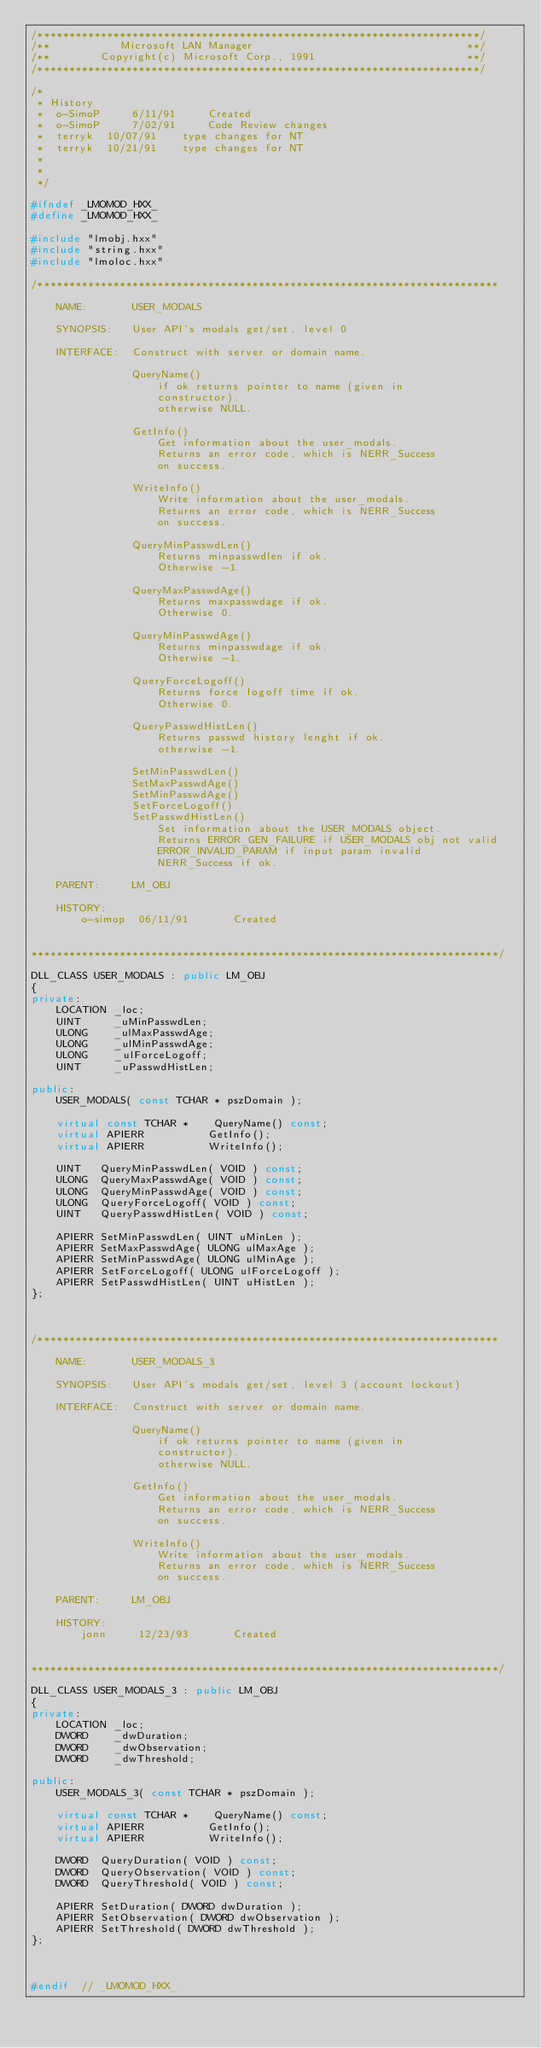Convert code to text. <code><loc_0><loc_0><loc_500><loc_500><_C++_>/**********************************************************************/
/**           Microsoft LAN Manager                                  **/
/**        Copyright(c) Microsoft Corp., 1991                        **/
/**********************************************************************/

/*
 * History
 *  o-SimoP     6/11/91     Created
 *  o-SimoP     7/02/91     Code Review changes
 *  terryk	10/07/91    type changes for NT
 *  terryk	10/21/91    type changes for NT
 *
 *
 */

#ifndef _LMOMOD_HXX_
#define _LMOMOD_HXX_

#include "lmobj.hxx"
#include "string.hxx"
#include "lmoloc.hxx"

/*************************************************************************

    NAME:       USER_MODALS

    SYNOPSIS:   User API's modals get/set, level 0

    INTERFACE:  Construct with server or domain name.

                QueryName()
                    if ok returns pointer to name (given in
                    constructor).
                    otherwise NULL.

                GetInfo()
                    Get information about the user_modals.
                    Returns an error code, which is NERR_Success
                    on success.

                WriteInfo()
                    Write information about the user_modals.
                    Returns an error code, which is NERR_Success
                    on success.

                QueryMinPasswdLen()
                    Returns minpasswdlen if ok.
                    Otherwise -1.

                QueryMaxPasswdAge()
                    Returns maxpasswdage if ok.
                    Otherwise 0.

                QueryMinPasswdAge()
                    Returns minpasswdage if ok.
                    Otherwise -1.

                QueryForceLogoff()
                    Returns force logoff time if ok.
                    Otherwise 0.

                QueryPasswdHistLen()
                    Returns passwd history lenght if ok.
                    otherwise -1.

                SetMinPasswdLen()
                SetMaxPasswdAge()
                SetMinPasswdAge()
                SetForceLogoff()
                SetPasswdHistLen()
                    Set information about the USER_MODALS object.
                    Returns ERROR_GEN_FAILURE if USER_MODALS obj not valid
                    ERROR_INVALID_PARAM if input param invalid
                    NERR_Success if ok.

    PARENT:     LM_OBJ

    HISTORY:
        o-simop  06/11/91       Created


**************************************************************************/

DLL_CLASS USER_MODALS : public LM_OBJ
{
private:
    LOCATION _loc;
    UINT     _uMinPasswdLen;
    ULONG    _ulMaxPasswdAge;
    ULONG    _ulMinPasswdAge;
    ULONG    _ulForceLogoff;
    UINT     _uPasswdHistLen;

public:
    USER_MODALS( const TCHAR * pszDomain );

    virtual const TCHAR *    QueryName() const;
    virtual APIERR          GetInfo();
    virtual APIERR          WriteInfo();

    UINT   QueryMinPasswdLen( VOID ) const;
    ULONG  QueryMaxPasswdAge( VOID ) const;
    ULONG  QueryMinPasswdAge( VOID ) const;
    ULONG  QueryForceLogoff( VOID ) const;
    UINT   QueryPasswdHistLen( VOID ) const;

    APIERR SetMinPasswdLen( UINT uMinLen );
    APIERR SetMaxPasswdAge( ULONG ulMaxAge );
    APIERR SetMinPasswdAge( ULONG ulMinAge );
    APIERR SetForceLogoff( ULONG ulForceLogoff );
    APIERR SetPasswdHistLen( UINT uHistLen );
};



/*************************************************************************

    NAME:       USER_MODALS_3

    SYNOPSIS:   User API's modals get/set, level 3 (account lockout)

    INTERFACE:  Construct with server or domain name.

                QueryName()
                    if ok returns pointer to name (given in
                    constructor).
                    otherwise NULL.

                GetInfo()
                    Get information about the user_modals.
                    Returns an error code, which is NERR_Success
                    on success.

                WriteInfo()
                    Write information about the user_modals.
                    Returns an error code, which is NERR_Success
                    on success.

    PARENT:     LM_OBJ

    HISTORY:
        jonn     12/23/93       Created


**************************************************************************/

DLL_CLASS USER_MODALS_3 : public LM_OBJ
{
private:
    LOCATION _loc;
    DWORD    _dwDuration;
    DWORD    _dwObservation;
    DWORD    _dwThreshold;

public:
    USER_MODALS_3( const TCHAR * pszDomain );

    virtual const TCHAR *    QueryName() const;
    virtual APIERR          GetInfo();
    virtual APIERR          WriteInfo();

    DWORD  QueryDuration( VOID ) const;
    DWORD  QueryObservation( VOID ) const;
    DWORD  QueryThreshold( VOID ) const;

    APIERR SetDuration( DWORD dwDuration );
    APIERR SetObservation( DWORD dwObservation );
    APIERR SetThreshold( DWORD dwThreshold );
};



#endif  // _LMOMOD_HXX_
</code> 